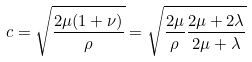Convert formula to latex. <formula><loc_0><loc_0><loc_500><loc_500>c = \sqrt { \frac { 2 \mu ( 1 + \nu ) } { \rho } } = \sqrt { \frac { 2 \mu } { \rho } \frac { 2 \mu + 2 \lambda } { 2 \mu + \lambda } }</formula> 